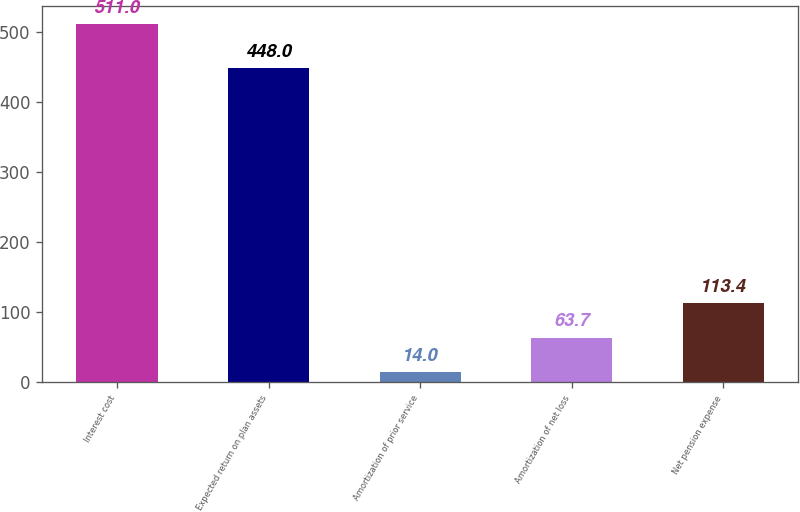Convert chart. <chart><loc_0><loc_0><loc_500><loc_500><bar_chart><fcel>Interest cost<fcel>Expected return on plan assets<fcel>Amortization of prior service<fcel>Amortization of net loss<fcel>Net pension expense<nl><fcel>511<fcel>448<fcel>14<fcel>63.7<fcel>113.4<nl></chart> 